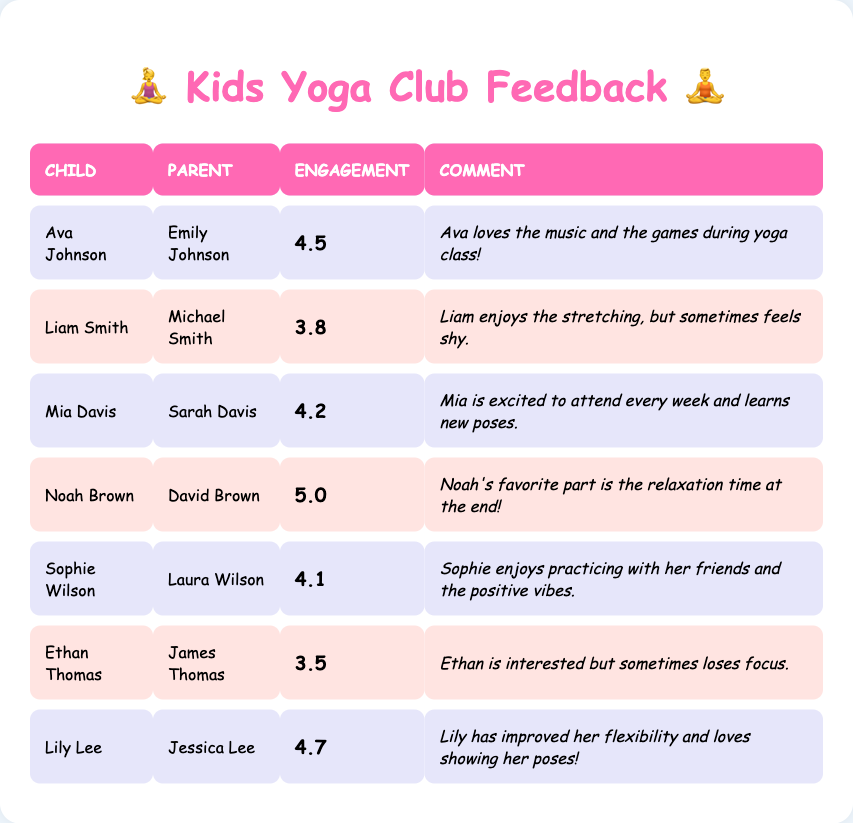What is the engagement rating for Ava Johnson? The table shows that Ava Johnson has a class engagement rating of 4.5.
Answer: 4.5 Which child received the highest engagement rating? The table indicates that Noah Brown received the highest engagement rating of 5.0.
Answer: Noah Brown What is the average engagement rating of all the children? The ratings are 4.5, 3.8, 4.2, 5.0, 4.1, 3.5, and 4.7. Adding these gives a total of 30.8. Since there are 7 children, the average is 30.8 divided by 7, which equals approximately 4.4.
Answer: 4.4 Did Mia Davis show enthusiasm for attending yoga classes? Mia's parent commented that "Mia is excited to attend every week," which indicates she showed enthusiasm.
Answer: Yes Is there a child who rated their engagement as 3.5 or lower? The table lists Ethan Thomas with an engagement rating of 3.5, which is lower than the reference value.
Answer: Yes What is the difference between the highest and lowest engagement ratings? The highest rating is 5.0 (Noah Brown) and the lowest rating is 3.5 (Ethan Thomas). The difference is 5.0 minus 3.5, which equals 1.5.
Answer: 1.5 How many parents commented that their child enjoys practicing with friends? Only Laura Wilson commented that Sophie enjoys practicing with her friends, indicating there is one instance of this.
Answer: 1 Which child enjoys relaxation time at the end of class? The comment from David Brown specifies that Noah Brown's favorite part is the relaxation time at the end of class.
Answer: Noah Brown 